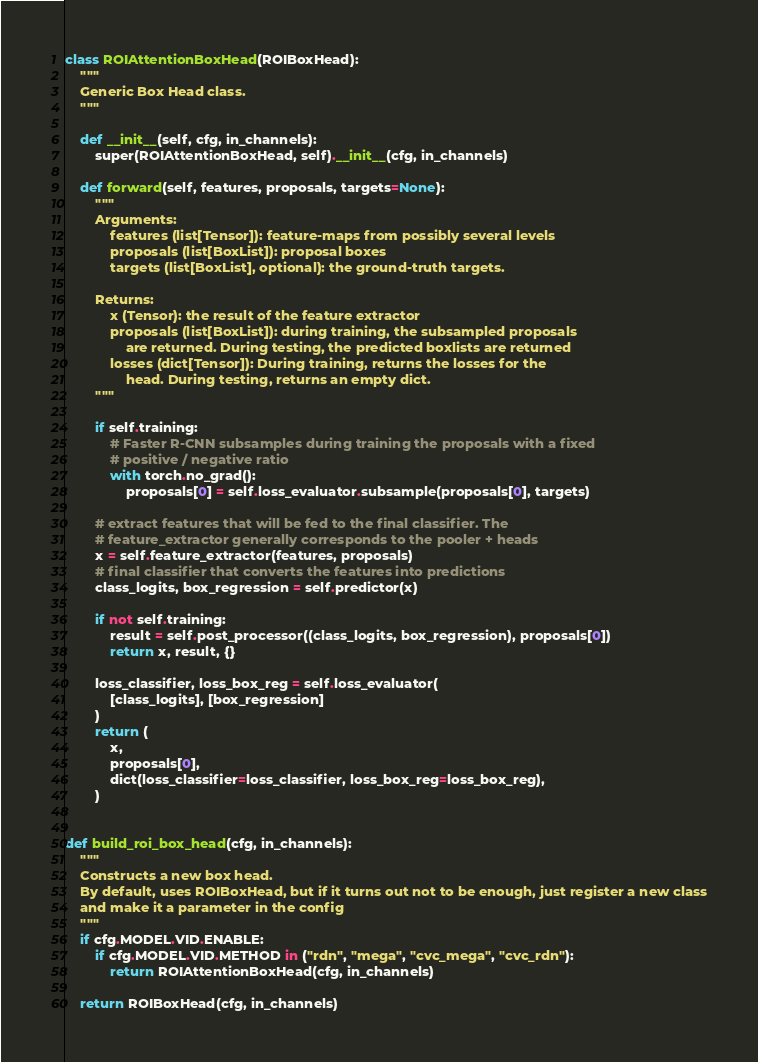<code> <loc_0><loc_0><loc_500><loc_500><_Python_>

class ROIAttentionBoxHead(ROIBoxHead):
    """
    Generic Box Head class.
    """

    def __init__(self, cfg, in_channels):
        super(ROIAttentionBoxHead, self).__init__(cfg, in_channels)

    def forward(self, features, proposals, targets=None):
        """
        Arguments:
            features (list[Tensor]): feature-maps from possibly several levels
            proposals (list[BoxList]): proposal boxes
            targets (list[BoxList], optional): the ground-truth targets.

        Returns:
            x (Tensor): the result of the feature extractor
            proposals (list[BoxList]): during training, the subsampled proposals
                are returned. During testing, the predicted boxlists are returned
            losses (dict[Tensor]): During training, returns the losses for the
                head. During testing, returns an empty dict.
        """

        if self.training:
            # Faster R-CNN subsamples during training the proposals with a fixed
            # positive / negative ratio
            with torch.no_grad():
                proposals[0] = self.loss_evaluator.subsample(proposals[0], targets)

        # extract features that will be fed to the final classifier. The
        # feature_extractor generally corresponds to the pooler + heads
        x = self.feature_extractor(features, proposals)
        # final classifier that converts the features into predictions
        class_logits, box_regression = self.predictor(x)

        if not self.training:
            result = self.post_processor((class_logits, box_regression), proposals[0])
            return x, result, {}

        loss_classifier, loss_box_reg = self.loss_evaluator(
            [class_logits], [box_regression]
        )
        return (
            x,
            proposals[0],
            dict(loss_classifier=loss_classifier, loss_box_reg=loss_box_reg),
        )


def build_roi_box_head(cfg, in_channels):
    """
    Constructs a new box head.
    By default, uses ROIBoxHead, but if it turns out not to be enough, just register a new class
    and make it a parameter in the config
    """
    if cfg.MODEL.VID.ENABLE:
        if cfg.MODEL.VID.METHOD in ("rdn", "mega", "cvc_mega", "cvc_rdn"):
            return ROIAttentionBoxHead(cfg, in_channels)

    return ROIBoxHead(cfg, in_channels)
</code> 